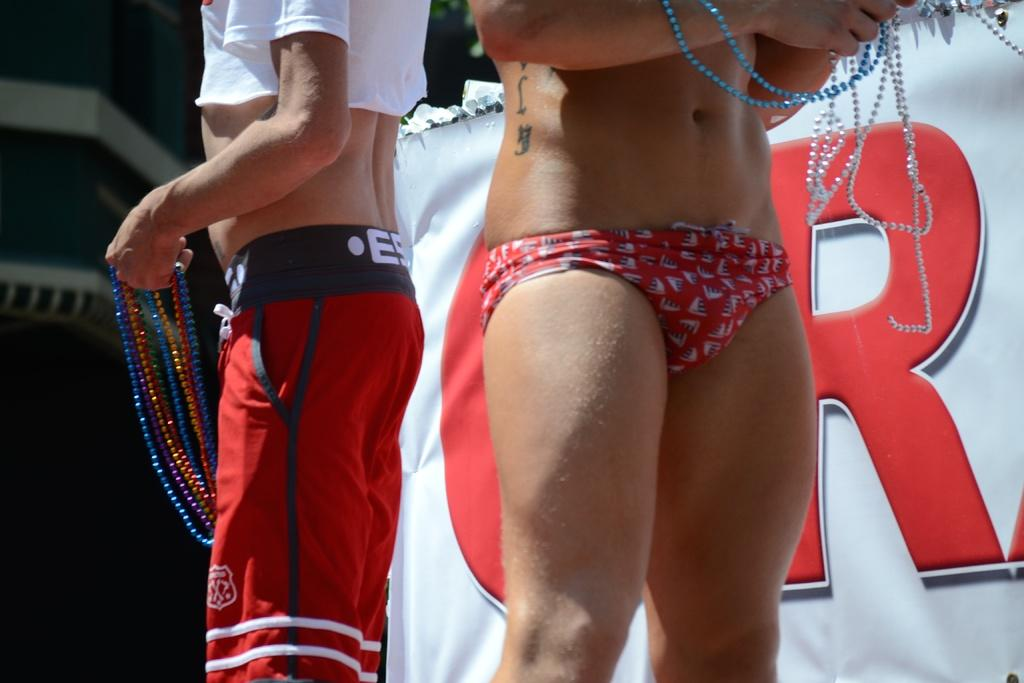<image>
Write a terse but informative summary of the picture. the bottom half of a man and a woman standing infront of a white banner with a red letter R written on it 